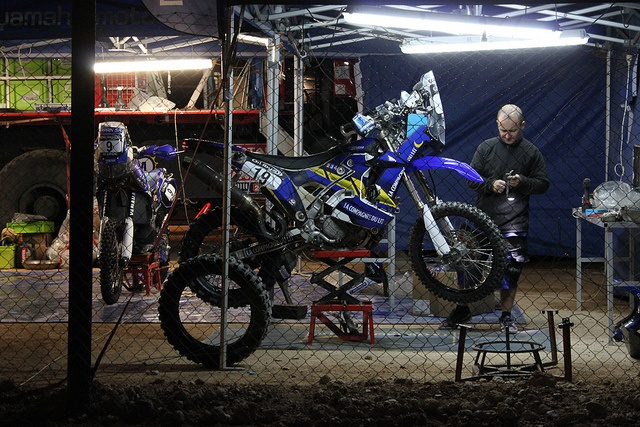Describe the objects in this image and their specific colors. I can see motorcycle in black, gray, navy, and darkgray tones, motorcycle in black, gray, darkgray, and navy tones, and people in black, gray, and darkgray tones in this image. 